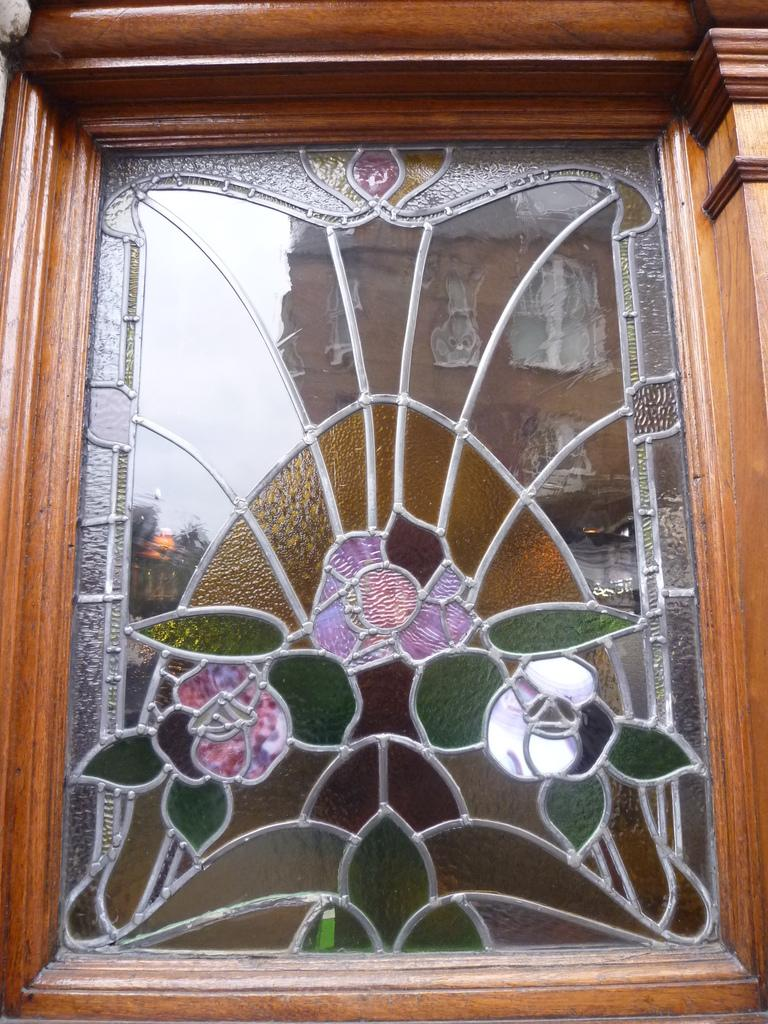What is depicted on the glass in the image? There is a painting on the glass in the image. What material is the wooden piece made of in the image? The wooden piece in the image is made of wood. What can be seen in the glass's reflection in the image? The glass has a reflection in the image. What type of structure is visible in the image? There is a building visible in the image. What part of the natural environment is visible in the image? The sky is visible in the image. What type of creature can be seen crawling on the wooden piece in the image? There is no creature present on the wooden piece in the image. In which room of the building is the glass and wooden piece located in the image? The image does not provide information about the room or location within the building. 